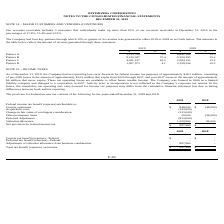According to Optimizerx Corporation's financial document, How many key partners that the Company had which 10% or greater of its revenue was generated in either 2019 or 2018? According to the financial document, four. The relevant text states: "ntages of 17.8%, 15.4% and 13.3%. The Company had four key partners through which 10% or greater of its revenue was generated in either 2019 or 2018 as se..." Also, What are the amounts of revenue generated from Partner B in 2018 and 2019, respectively? The document shows two values: 5,350,393 and 9,210,347. From the document: "Partner B 9,210,347 37.4 5,350,393 25.2 Partner B 9,210,347 37.4 5,350,393 25.2..." Also, What are the amounts of revenue generated from Partner A in 2018 and 2019, respectively? The document shows two values: 6,841,386 and 1,315,706. From the document: "Partner A 1,315,706 5.3 6,841,386 32.3 Partner A 1,315,706 5.3 6,841,386 32.3..." Also, can you calculate: What is the percentage change in revenue generated from Partner C from 2018 to 2019? To answer this question, I need to perform calculations using the financial data. The calculation is: (4,051,217-2,584,103)/2,584,103 , which equals 56.77 (percentage). This is based on the information: "Partner C 4,051,217 16.5 2,584,103 12.2 Partner C 4,051,217 16.5 2,584,103 12.2..." The key data points involved are: 2,584,103, 4,051,217. Additionally, Which partner contributed the highest revenue to the Company in 2018? According to the financial document, Partner A. The relevant text states: "Partner A 1,315,706 5.3 6,841,386 32.3..." Also, can you calculate: What is the average revenue generated from Partner D in the last 2 years, i.e. 2018 and 2019? To answer this question, I need to perform calculations using the financial data. The calculation is: (1,007,573+2,159,356)/2 , which equals 1583464.5. This is based on the information: "Partner D 1,007,573 4.1 2,159,356 10.2 Partner D 1,007,573 4.1 2,159,356 10.2..." The key data points involved are: 1,007,573, 2,159,356. 